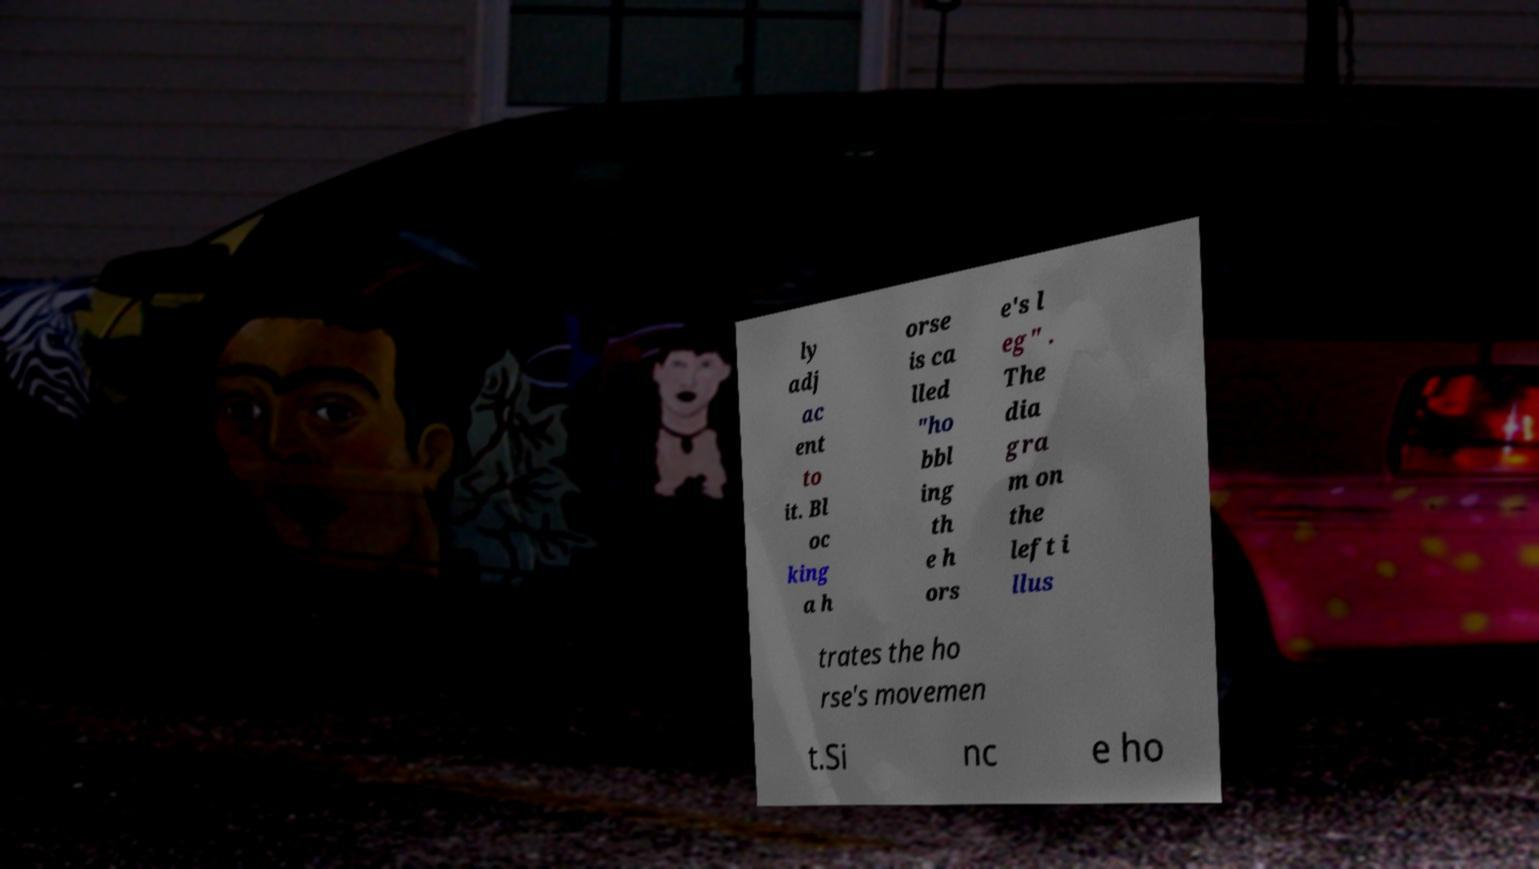Please read and relay the text visible in this image. What does it say? ly adj ac ent to it. Bl oc king a h orse is ca lled "ho bbl ing th e h ors e's l eg" . The dia gra m on the left i llus trates the ho rse's movemen t.Si nc e ho 